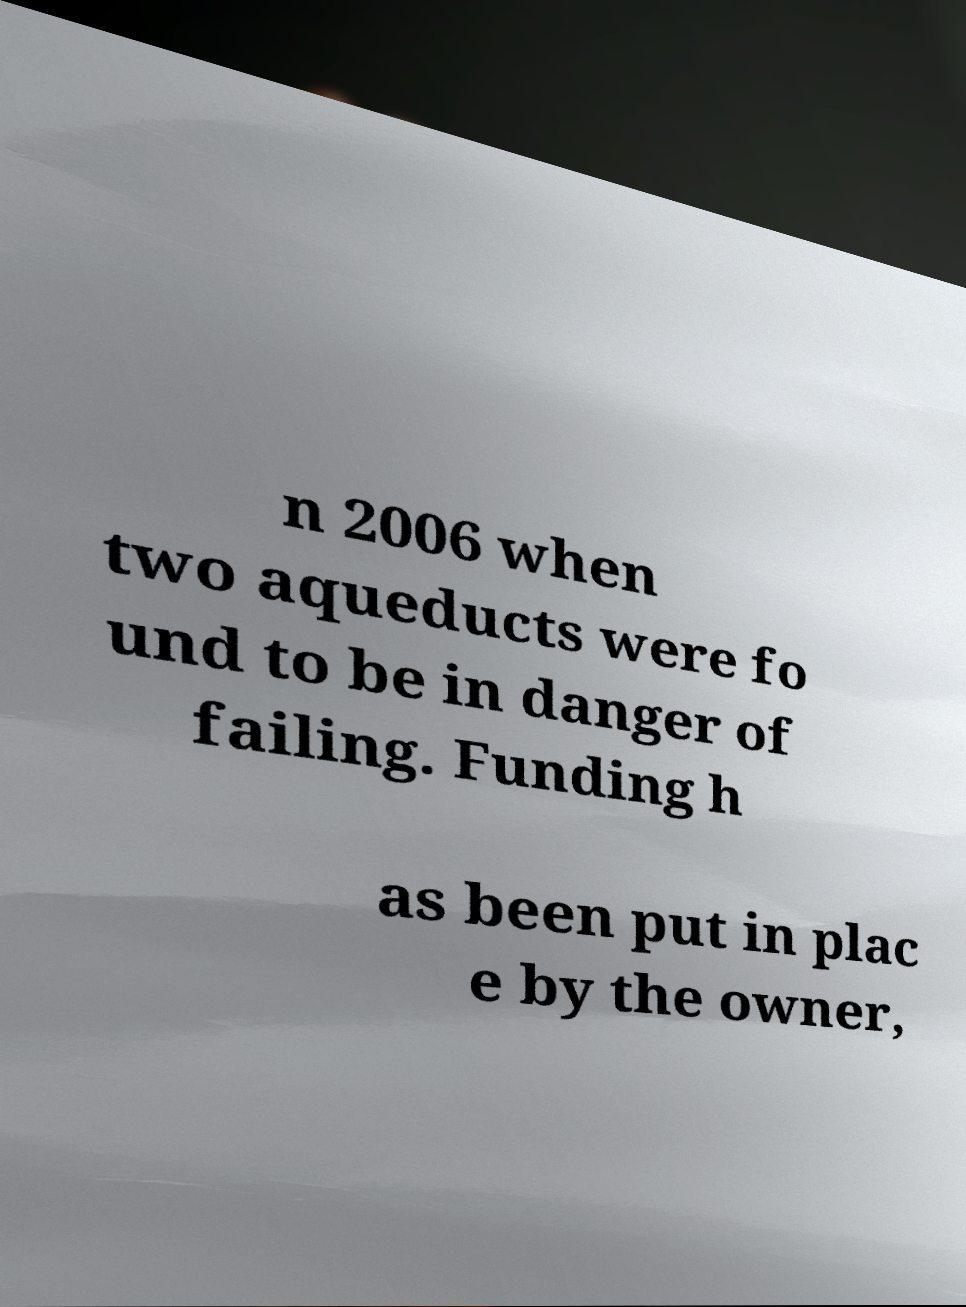Please identify and transcribe the text found in this image. n 2006 when two aqueducts were fo und to be in danger of failing. Funding h as been put in plac e by the owner, 